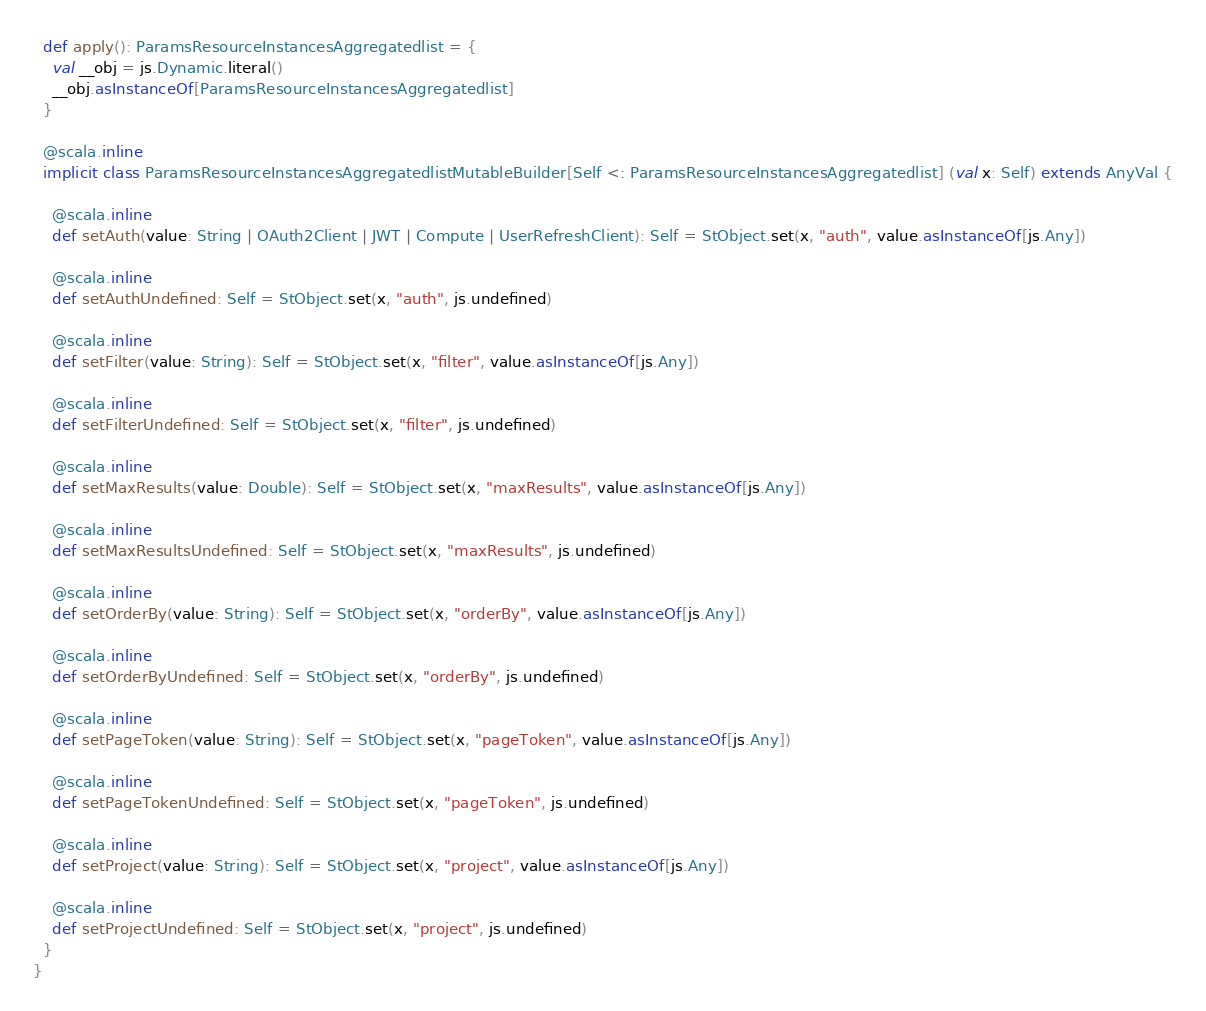Convert code to text. <code><loc_0><loc_0><loc_500><loc_500><_Scala_>  def apply(): ParamsResourceInstancesAggregatedlist = {
    val __obj = js.Dynamic.literal()
    __obj.asInstanceOf[ParamsResourceInstancesAggregatedlist]
  }
  
  @scala.inline
  implicit class ParamsResourceInstancesAggregatedlistMutableBuilder[Self <: ParamsResourceInstancesAggregatedlist] (val x: Self) extends AnyVal {
    
    @scala.inline
    def setAuth(value: String | OAuth2Client | JWT | Compute | UserRefreshClient): Self = StObject.set(x, "auth", value.asInstanceOf[js.Any])
    
    @scala.inline
    def setAuthUndefined: Self = StObject.set(x, "auth", js.undefined)
    
    @scala.inline
    def setFilter(value: String): Self = StObject.set(x, "filter", value.asInstanceOf[js.Any])
    
    @scala.inline
    def setFilterUndefined: Self = StObject.set(x, "filter", js.undefined)
    
    @scala.inline
    def setMaxResults(value: Double): Self = StObject.set(x, "maxResults", value.asInstanceOf[js.Any])
    
    @scala.inline
    def setMaxResultsUndefined: Self = StObject.set(x, "maxResults", js.undefined)
    
    @scala.inline
    def setOrderBy(value: String): Self = StObject.set(x, "orderBy", value.asInstanceOf[js.Any])
    
    @scala.inline
    def setOrderByUndefined: Self = StObject.set(x, "orderBy", js.undefined)
    
    @scala.inline
    def setPageToken(value: String): Self = StObject.set(x, "pageToken", value.asInstanceOf[js.Any])
    
    @scala.inline
    def setPageTokenUndefined: Self = StObject.set(x, "pageToken", js.undefined)
    
    @scala.inline
    def setProject(value: String): Self = StObject.set(x, "project", value.asInstanceOf[js.Any])
    
    @scala.inline
    def setProjectUndefined: Self = StObject.set(x, "project", js.undefined)
  }
}
</code> 